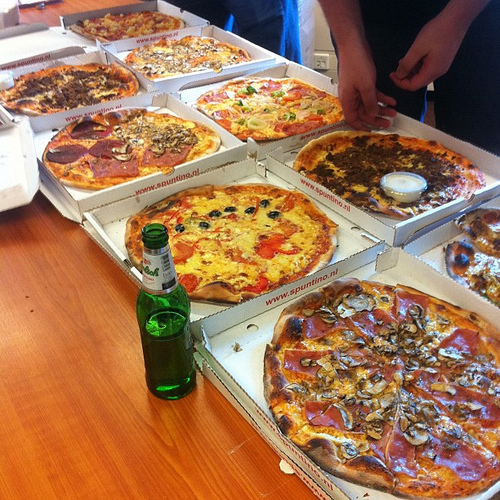Is the white container to the left or to the right of the box that is in the center? The white container is to the right of the box that is in the center. 